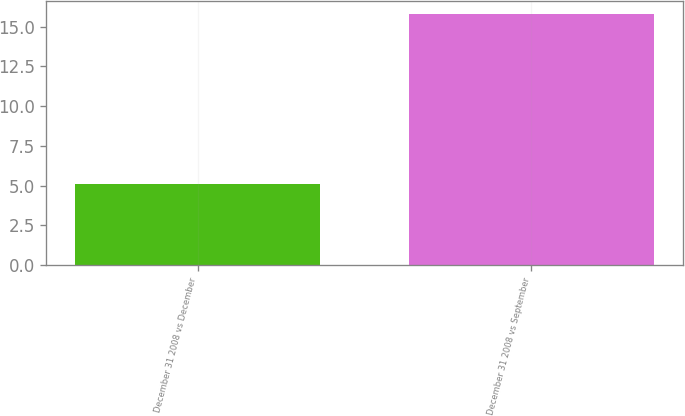<chart> <loc_0><loc_0><loc_500><loc_500><bar_chart><fcel>December 31 2008 vs December<fcel>December 31 2008 vs September<nl><fcel>5.1<fcel>15.8<nl></chart> 